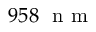<formula> <loc_0><loc_0><loc_500><loc_500>9 5 8 n m</formula> 